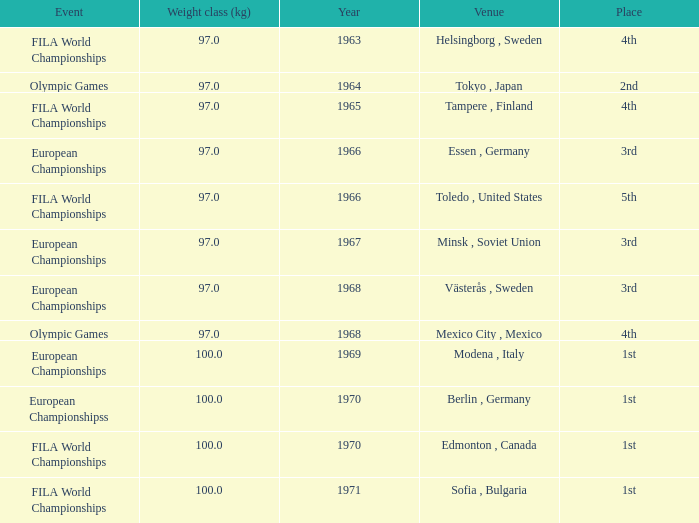What is the lowest year that has edmonton, canada as the venue with a weight class (kg) greater than 100? None. 